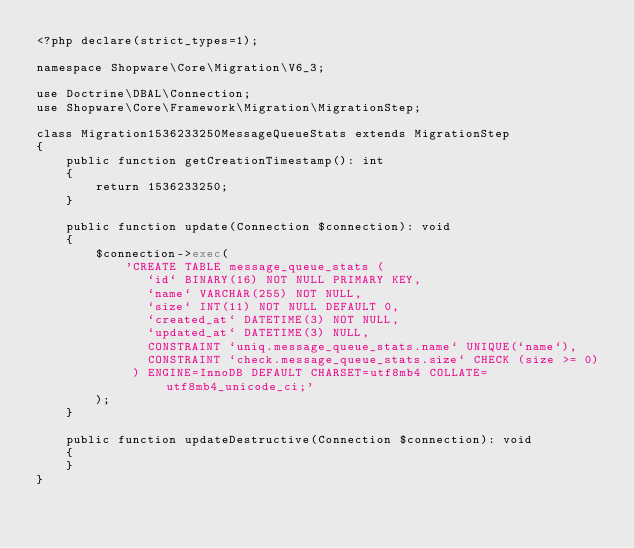<code> <loc_0><loc_0><loc_500><loc_500><_PHP_><?php declare(strict_types=1);

namespace Shopware\Core\Migration\V6_3;

use Doctrine\DBAL\Connection;
use Shopware\Core\Framework\Migration\MigrationStep;

class Migration1536233250MessageQueueStats extends MigrationStep
{
    public function getCreationTimestamp(): int
    {
        return 1536233250;
    }

    public function update(Connection $connection): void
    {
        $connection->exec(
            'CREATE TABLE message_queue_stats (
               `id` BINARY(16) NOT NULL PRIMARY KEY,
               `name` VARCHAR(255) NOT NULL,
               `size` INT(11) NOT NULL DEFAULT 0,
               `created_at` DATETIME(3) NOT NULL,
               `updated_at` DATETIME(3) NULL,
               CONSTRAINT `uniq.message_queue_stats.name` UNIQUE(`name`),
               CONSTRAINT `check.message_queue_stats.size` CHECK (size >= 0)
             ) ENGINE=InnoDB DEFAULT CHARSET=utf8mb4 COLLATE=utf8mb4_unicode_ci;'
        );
    }

    public function updateDestructive(Connection $connection): void
    {
    }
}
</code> 